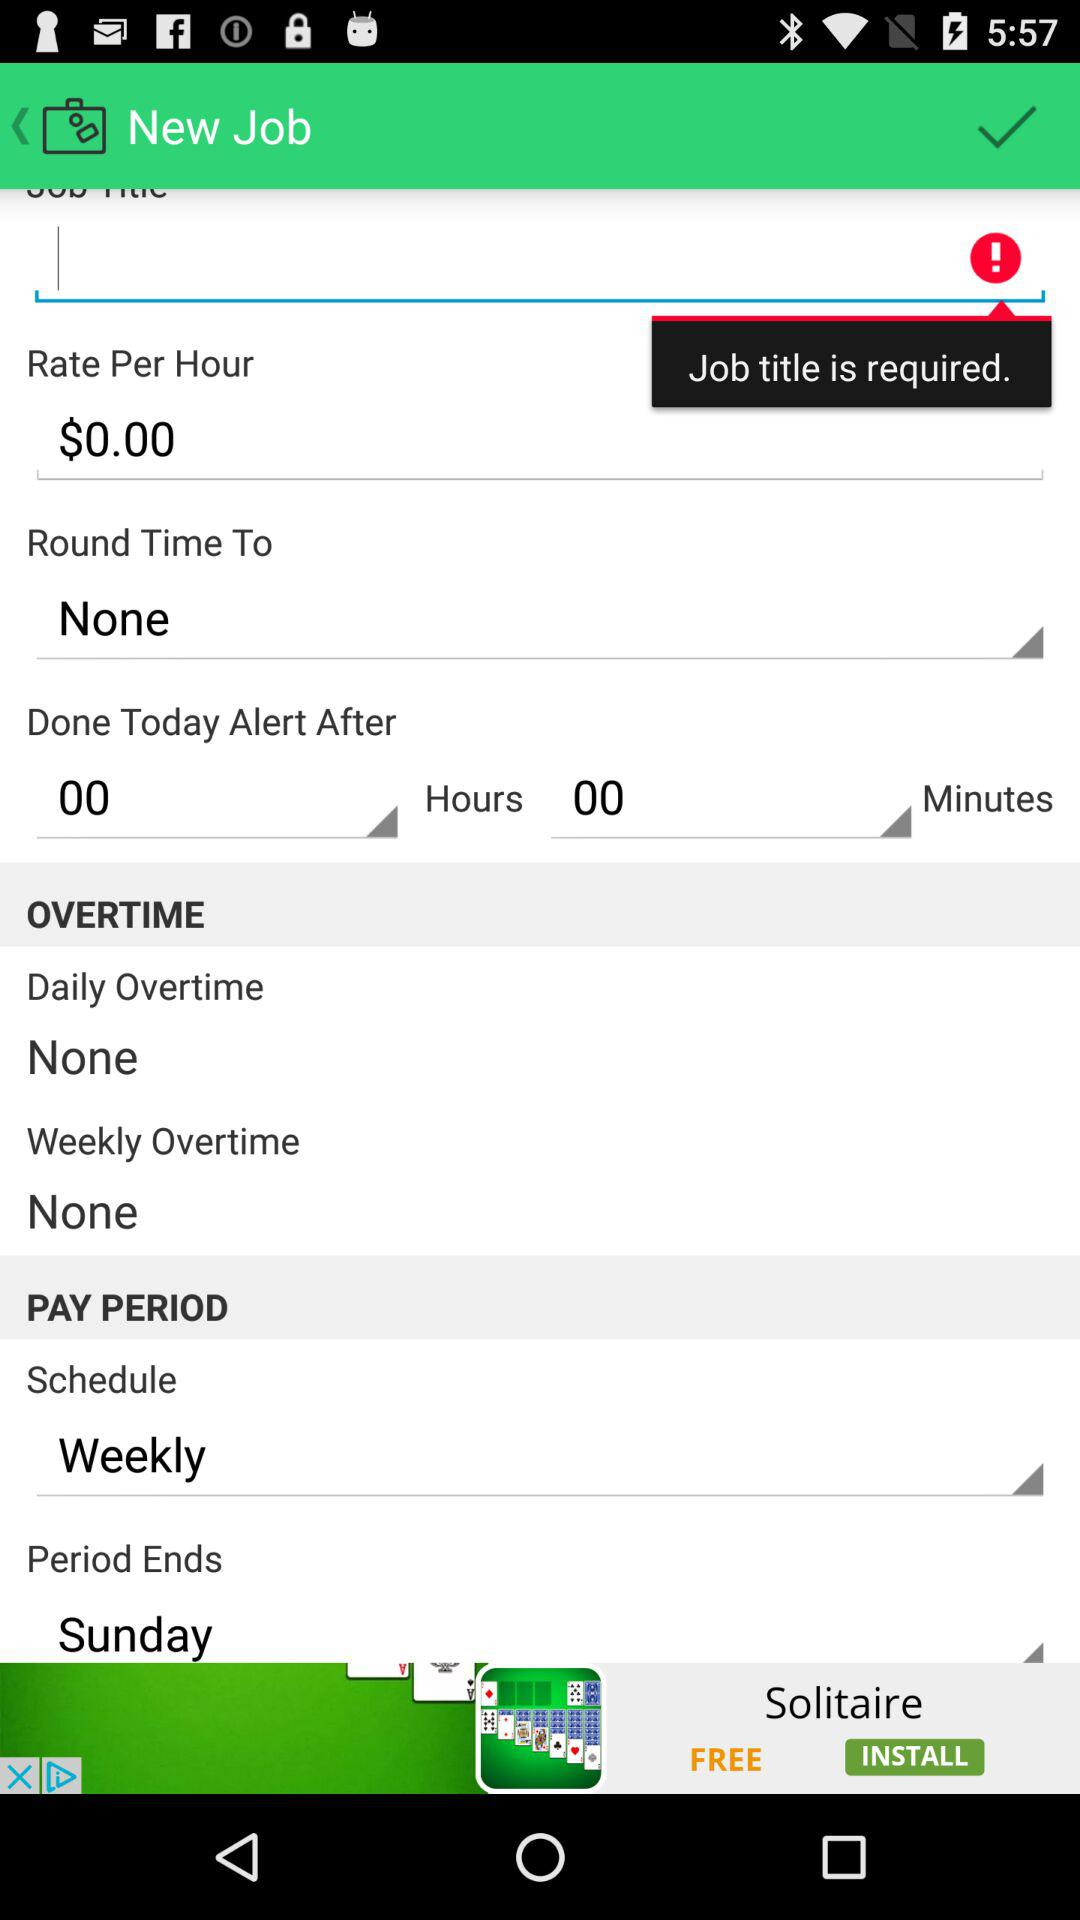What is the pay period end day? The pay period end day is Sunday. 